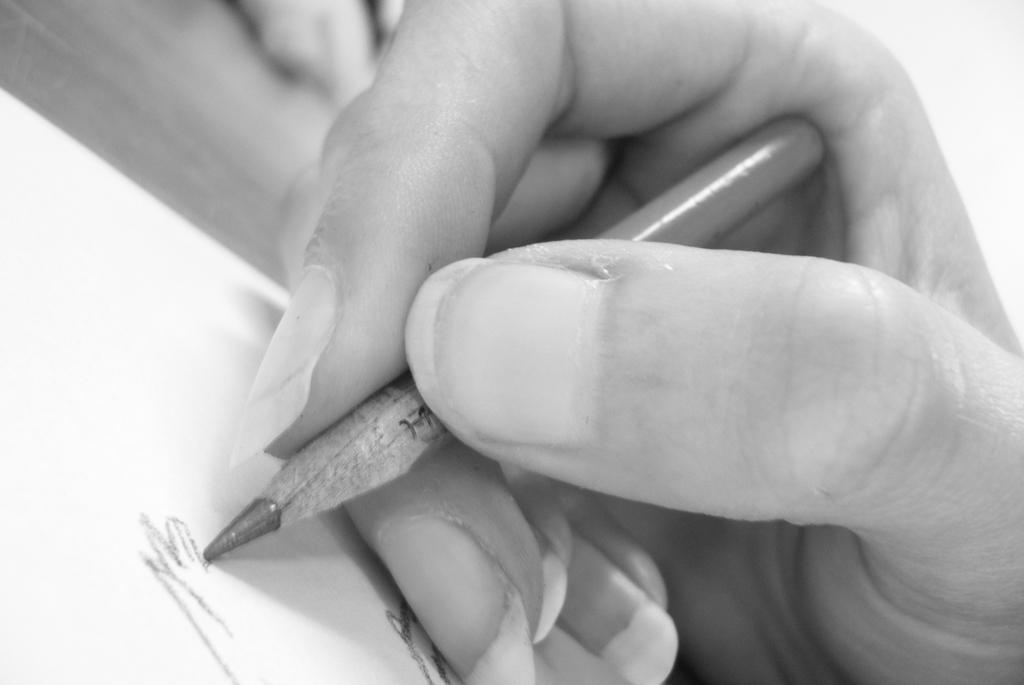What is the human hand in the image holding? The hand is holding a pencil. What is the hand doing with the pencil? The hand is writing on a piece of paper. Where is the paper located? The paper is on a table. What type of shape is the hand drawing in the image? There is no specific shape mentioned in the image, as the hand is simply writing on a piece of paper. 